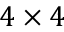<formula> <loc_0><loc_0><loc_500><loc_500>4 \times 4</formula> 